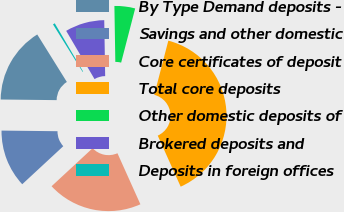Convert chart. <chart><loc_0><loc_0><loc_500><loc_500><pie_chart><fcel>By Type Demand deposits -<fcel>Savings and other domestic<fcel>Core certificates of deposit<fcel>Total core deposits<fcel>Other domestic deposits of<fcel>Brokered deposits and<fcel>Deposits in foreign offices<nl><fcel>15.95%<fcel>12.07%<fcel>19.83%<fcel>39.24%<fcel>4.3%<fcel>8.19%<fcel>0.42%<nl></chart> 